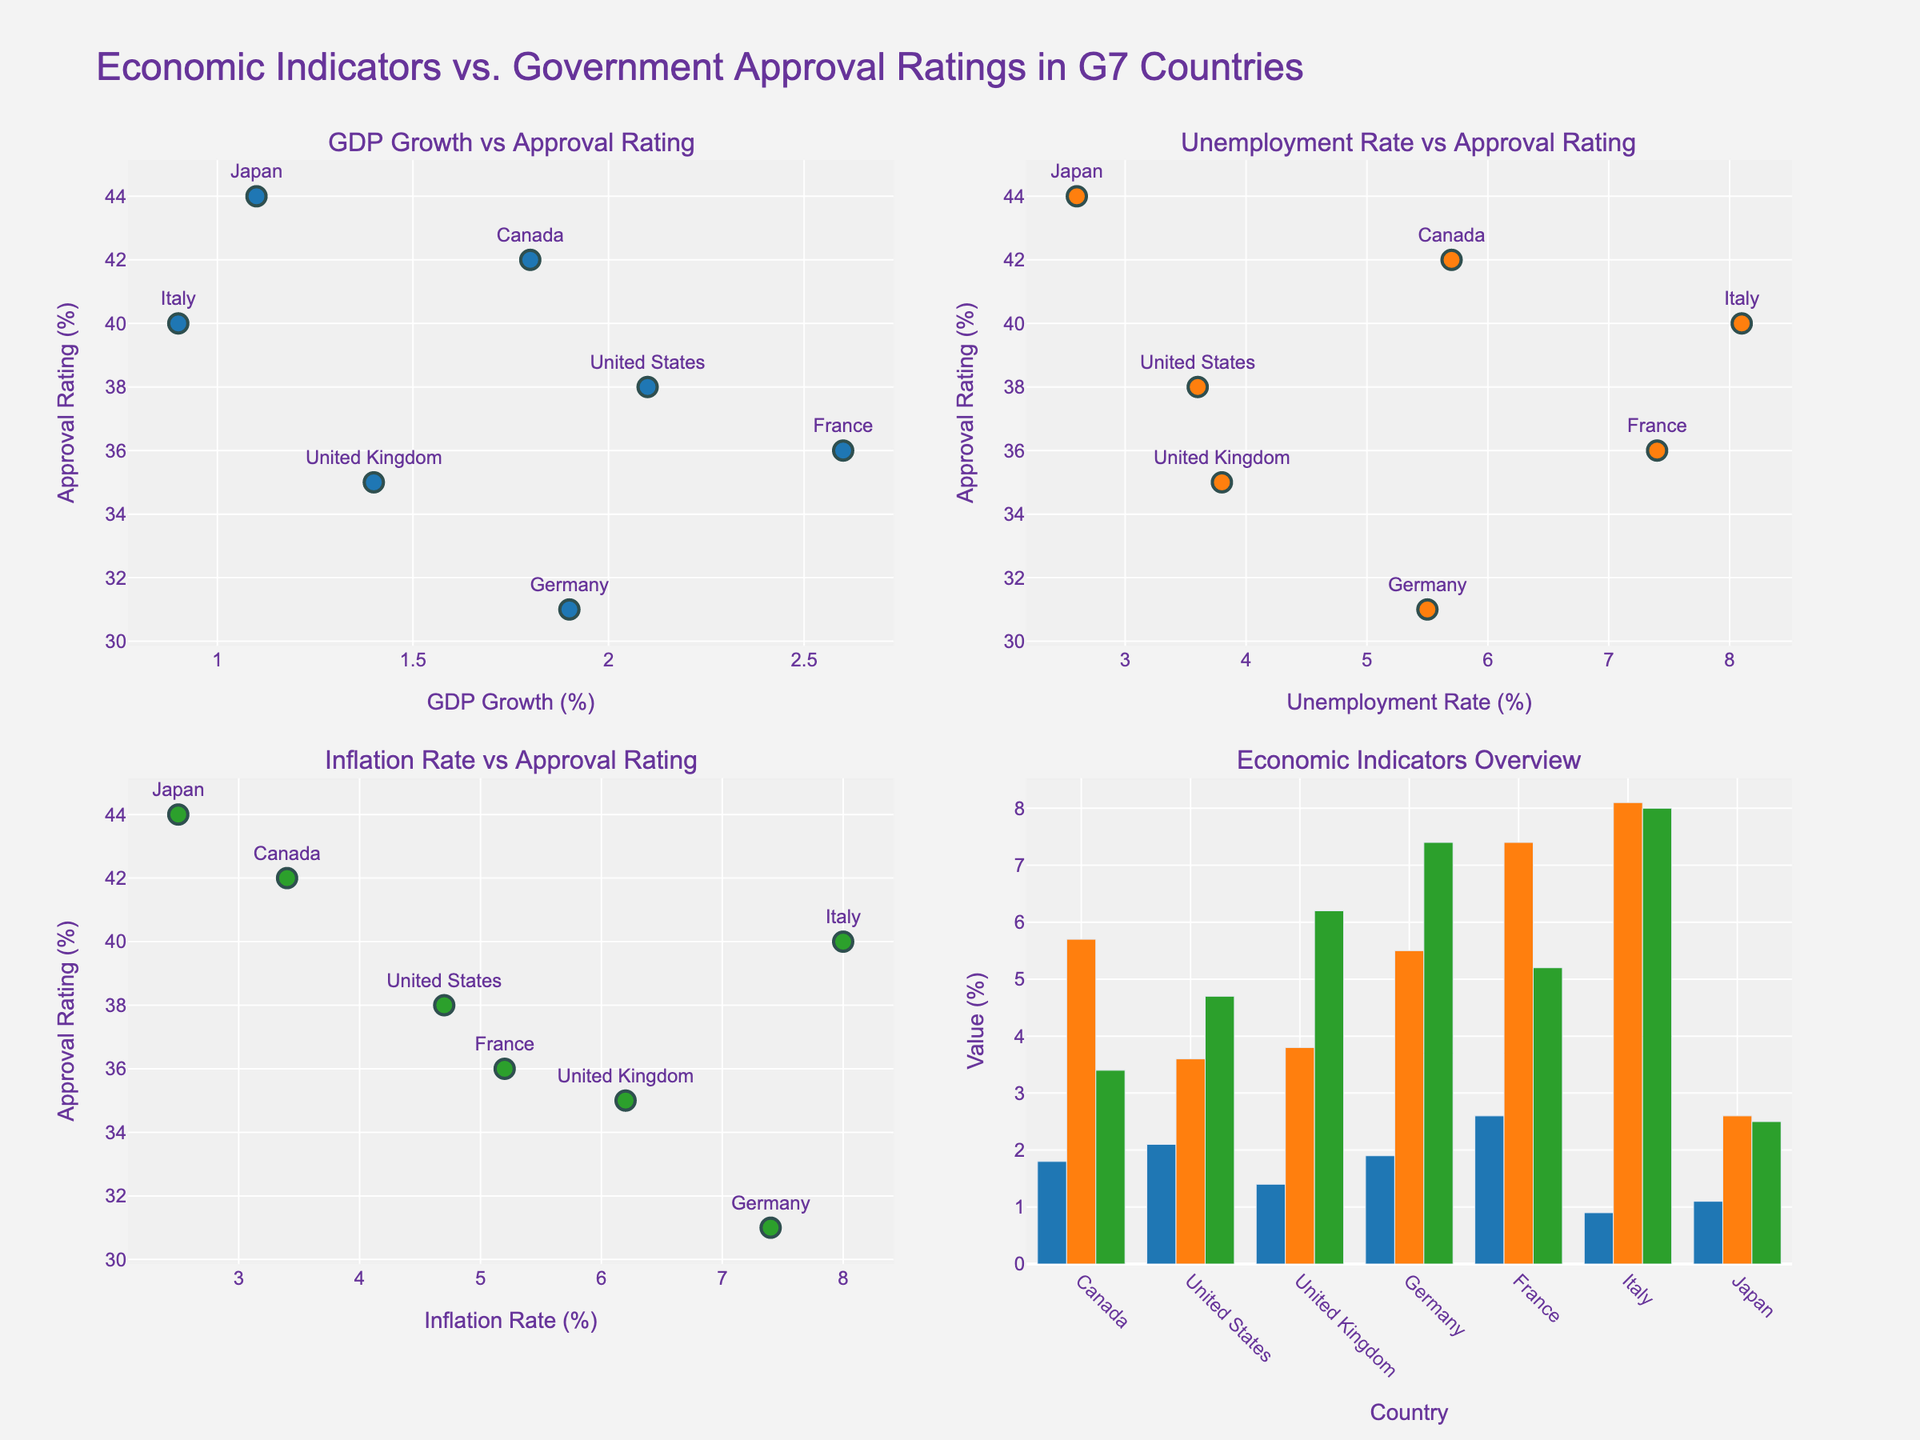What is the title of the figure? The title of the figure is written at the top of the plot. The text is "Economic Indicators vs. Government Approval Ratings in G7 Countries".
Answer: Economic Indicators vs. Government Approval Ratings in G7 Countries What does the y-axis represent in the subplots? The y-axis label is the same for all subplots, and it is "Approval Rating (%)".
Answer: Approval Rating (%) How many data points are there in each scatter plot? Looking at the number of markers in each scatter plot, representing the countries, there are seven data points.
Answer: 7 Which country has the highest government approval rating and what is its GDP growth rate? In the scatter plot "GDP Growth vs Approval Rating", we can find the highest data point on the y-axis, which is Japan at 44%. By looking at the corresponding x-axis value, we find that Japan has a GDP growth rate of 1.1%.
Answer: Japan, 1.1% Does a higher GDP growth rate always correlate with a higher government approval rating? By examining the scatter plot "GDP Growth vs Approval Rating", we will notice that there isn't a straightforward correlation. For example, Canada has relatively high GDP growth (1.8%) but moderate approval ratings (42%), whereas Japan has the highest approval rating (44%) but low GDP growth (1.1%).
Answer: No Which country has the highest unemployment rate and what is its approval rating? We look at the scatter plot "Unemployment Rate vs Approval Rating" to find the highest point on the x-axis, which is Italy at 8.1%. The corresponding point on the y-axis shows that Italy's approval rating is 40%.
Answer: Italy, 40% Is there an inverse relationship between inflation rate and government approval rating? By examining the scatter plot "Inflation Rate vs Approval Rating", we look for an inverse pattern where higher inflation corresponds to lower approval. Countries with high inflation like Germany (7.4%) have lower approval (31%), and those with lower inflation like Japan (2.5%) have higher approval (44%). No strict inverse pattern but a general tendency is observable.
Answer: Generally, yes Which two countries have the closest GDP growth rates? What are their approval ratings? By closely examining the "GDP Growth vs Approval Rating" subplot, we can see that Canada and Germany have very close GDP growth rates (1.8% and 1.9%). Canada has an approval rating of 42%, while Germany has an approval rating of 31%.
Answer: Canada with 42%, Germany with 31% On average, do countries with higher or lower unemployment rates tend to have higher approval ratings? By looking at the "Unemployment Rate vs Approval Rating" scatter plot:
- Lower unemployment rates: Japan (2.6%), USA (3.6%), UK (3.8%) tend to have mixed approval ratings averaging around mid-40s to 30s.
- Higher unemployment rates: France (7.4%), Italy (8.1%) have relatively lower approval ratings averaging around high 30s.
On average, lower unemployment rates tend to have higher approval ratings.
Answer: Lower 